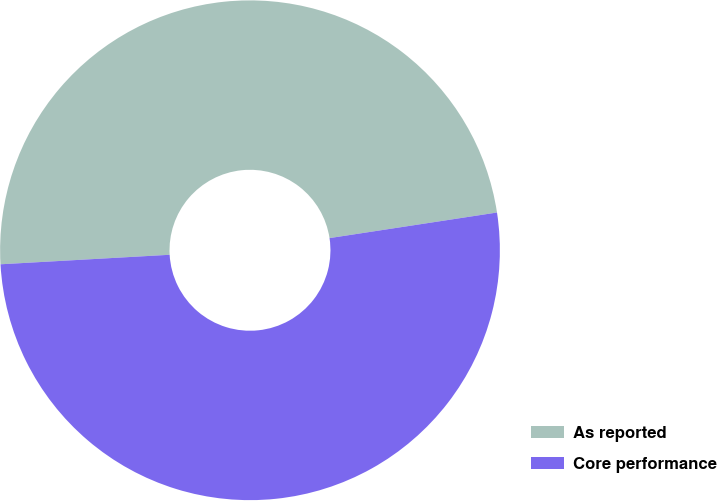Convert chart. <chart><loc_0><loc_0><loc_500><loc_500><pie_chart><fcel>As reported<fcel>Core performance<nl><fcel>48.48%<fcel>51.52%<nl></chart> 